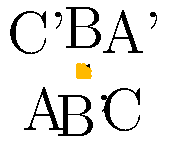The West Coast Eagles logo is represented by triangle ABC in the coordinate plane. If the logo is reflected across the line y = x, what are the coordinates of point B' (the reflection of point B)? To find the coordinates of B' after reflecting triangle ABC across the line y = x, we can follow these steps:

1. Identify the original coordinates of point B:
   B is located at (1, 2)

2. Understand the reflection across y = x:
   When reflecting across y = x, the x and y coordinates are swapped.

3. Apply the reflection:
   For point B (1, 2):
   - The x-coordinate (1) becomes the new y-coordinate
   - The y-coordinate (2) becomes the new x-coordinate

4. Determine the new coordinates:
   B' will have coordinates (2, 1)

5. Verify visually:
   In the diagram, we can see that B' is indeed located at (2, 1)

Therefore, the coordinates of B' after reflection are (2, 1).
Answer: (2, 1) 